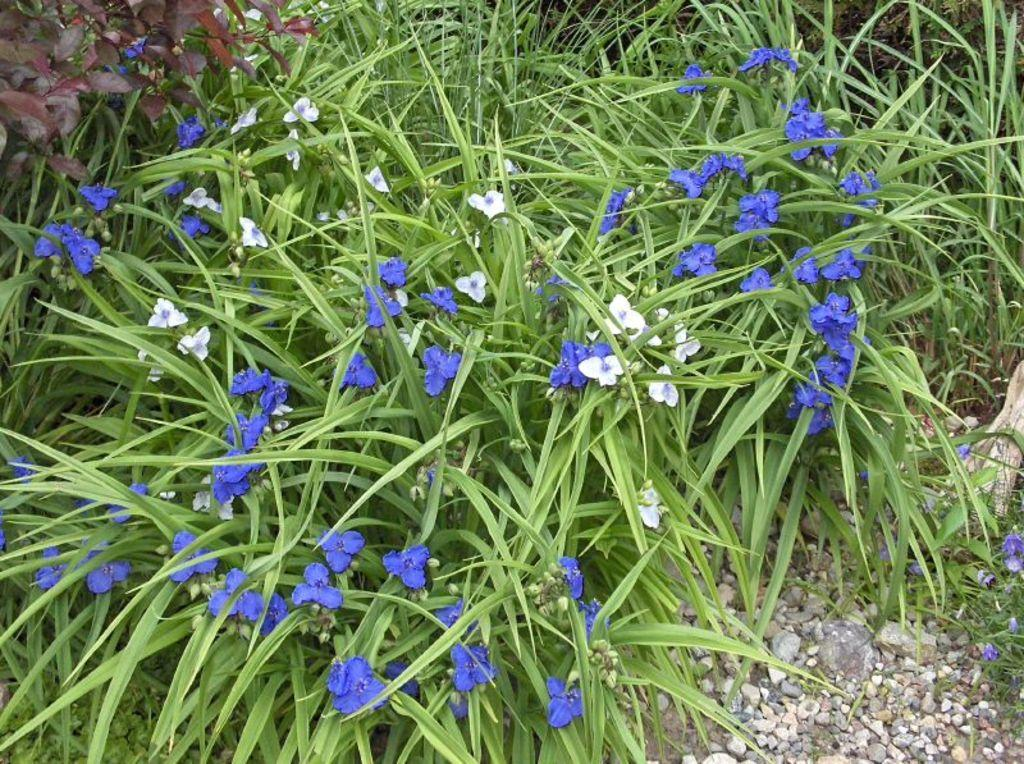What type of vegetation is predominant in the image? There is a lot of grass in the image. Are there any other plants visible among the grass? Yes, there are flowers among the grass. What can be seen in the front of the image? There are small stones in the front of the image. How many bombs are hidden among the grass in the image? There are no bombs present in the image; it features grass, flowers, and small stones. 